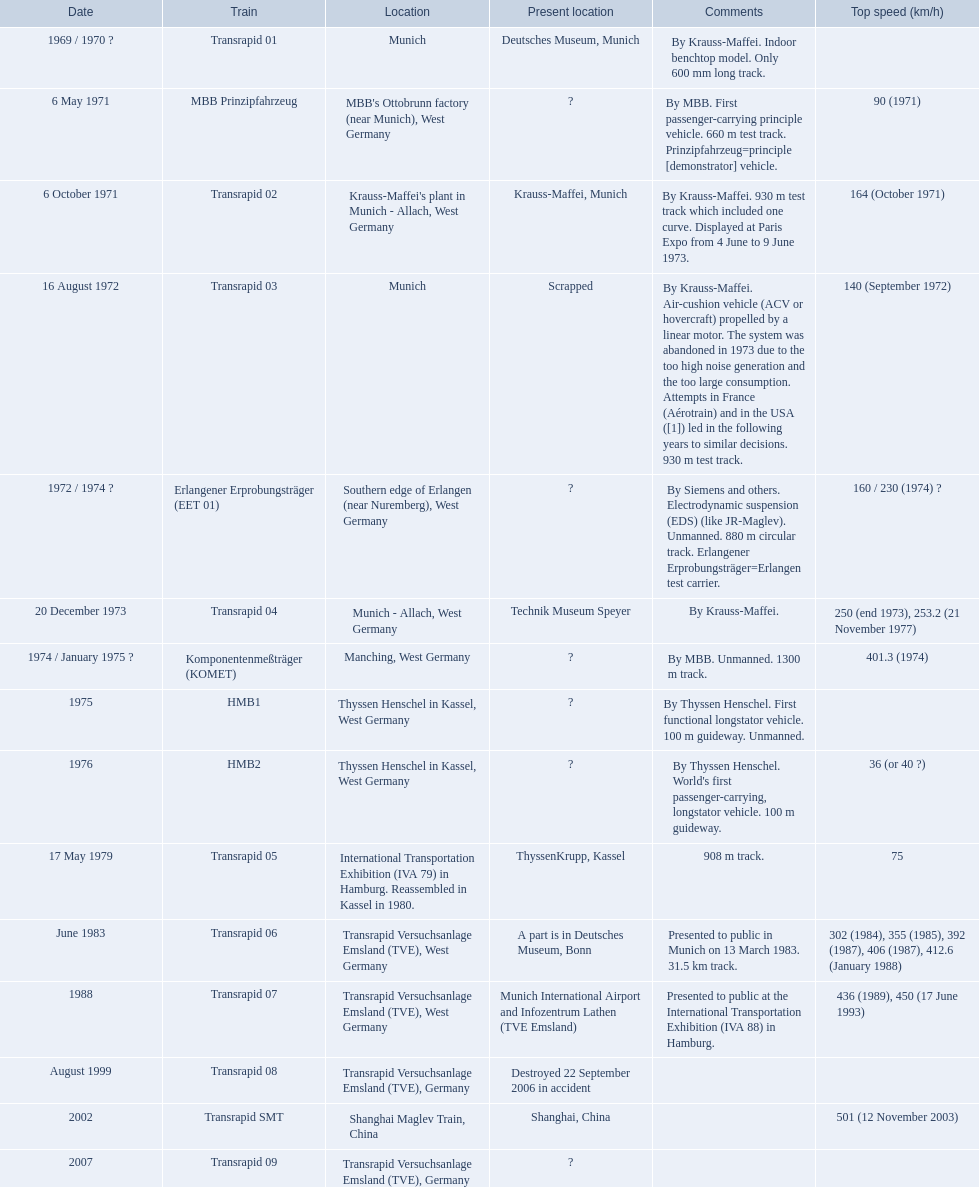What are the names of each transrapid train? Transrapid 01, MBB Prinzipfahrzeug, Transrapid 02, Transrapid 03, Erlangener Erprobungsträger (EET 01), Transrapid 04, Komponentenmeßträger (KOMET), HMB1, HMB2, Transrapid 05, Transrapid 06, Transrapid 07, Transrapid 08, Transrapid SMT, Transrapid 09. What are their listed top speeds? 90 (1971), 164 (October 1971), 140 (September 1972), 160 / 230 (1974) ?, 250 (end 1973), 253.2 (21 November 1977), 401.3 (1974), 36 (or 40 ?), 75, 302 (1984), 355 (1985), 392 (1987), 406 (1987), 412.6 (January 1988), 436 (1989), 450 (17 June 1993), 501 (12 November 2003). And which train operates at the fastest speed? Transrapid SMT. 